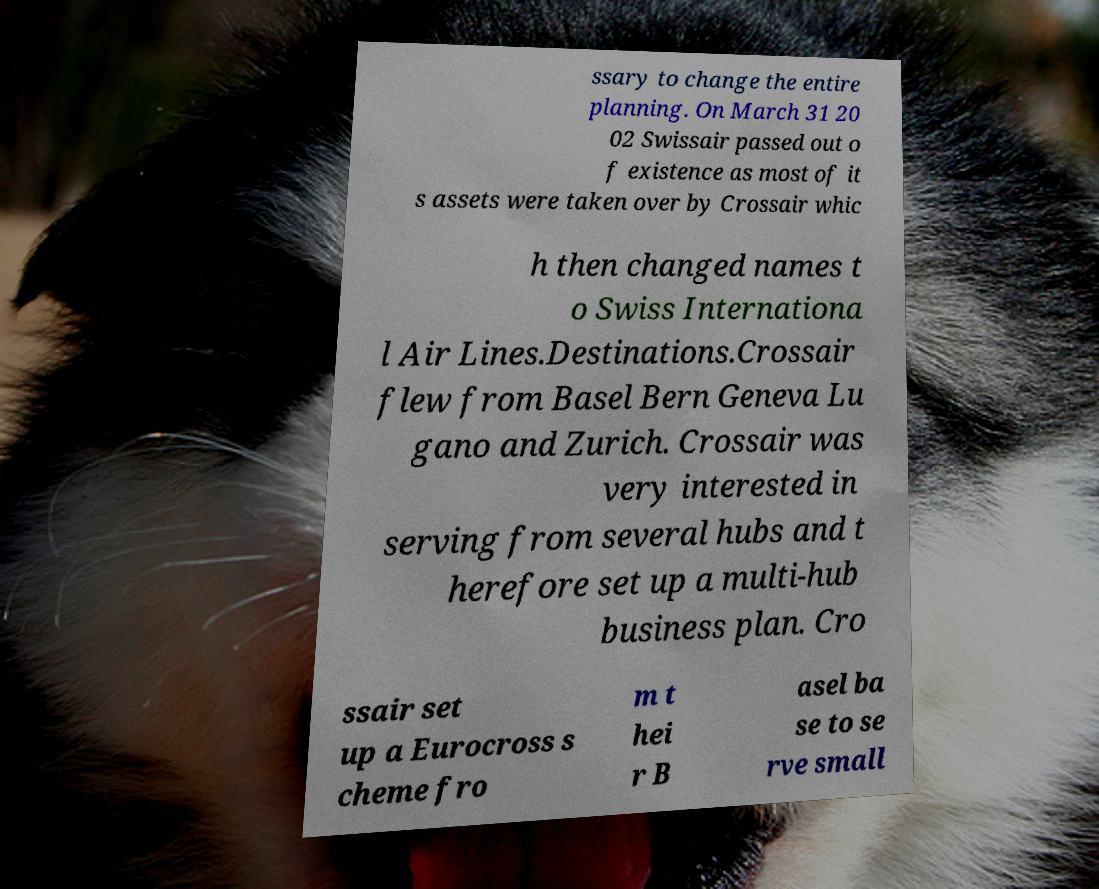Could you extract and type out the text from this image? ssary to change the entire planning. On March 31 20 02 Swissair passed out o f existence as most of it s assets were taken over by Crossair whic h then changed names t o Swiss Internationa l Air Lines.Destinations.Crossair flew from Basel Bern Geneva Lu gano and Zurich. Crossair was very interested in serving from several hubs and t herefore set up a multi-hub business plan. Cro ssair set up a Eurocross s cheme fro m t hei r B asel ba se to se rve small 